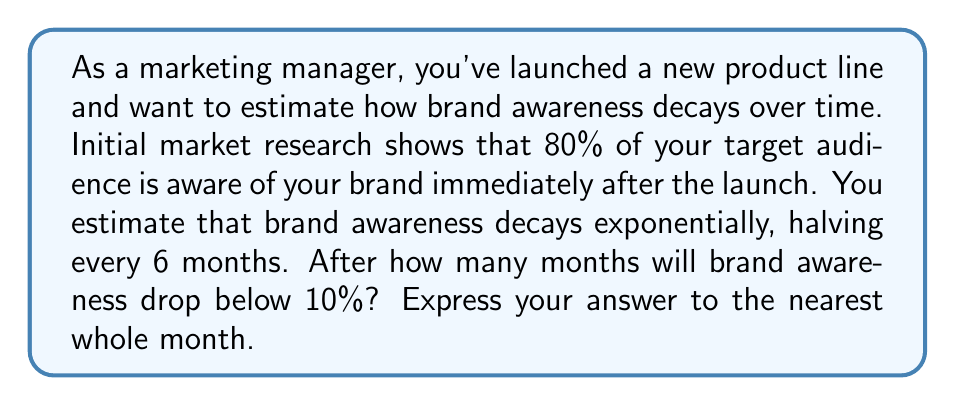Can you answer this question? Let's approach this step-by-step using an exponential decay model:

1) Let $A(t)$ be the brand awareness at time $t$ (in months), and $A_0$ be the initial awareness.

2) The exponential decay model is given by:
   $$A(t) = A_0 \cdot 2^{-t/h}$$
   where $h$ is the half-life (in this case, 6 months).

3) We're given:
   $A_0 = 80\%$ (initial awareness)
   $h = 6$ months (half-life)

4) We want to find $t$ when $A(t) < 10\%$. Let's set up the equation:
   $$10 = 80 \cdot 2^{-t/6}$$

5) Dividing both sides by 80:
   $$\frac{1}{8} = 2^{-t/6}$$

6) Taking the logarithm (base 2) of both sides:
   $$\log_2(\frac{1}{8}) = -\frac{t}{6}$$

7) Simplify the left side:
   $$-3 = -\frac{t}{6}$$

8) Multiply both sides by -6:
   $$18 = t$$

Therefore, brand awareness will drop below 10% after 18 months.
Answer: 18 months 